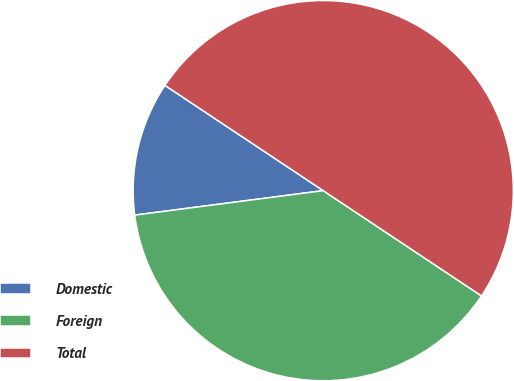Convert chart. <chart><loc_0><loc_0><loc_500><loc_500><pie_chart><fcel>Domestic<fcel>Foreign<fcel>Total<nl><fcel>11.4%<fcel>38.6%<fcel>50.0%<nl></chart> 